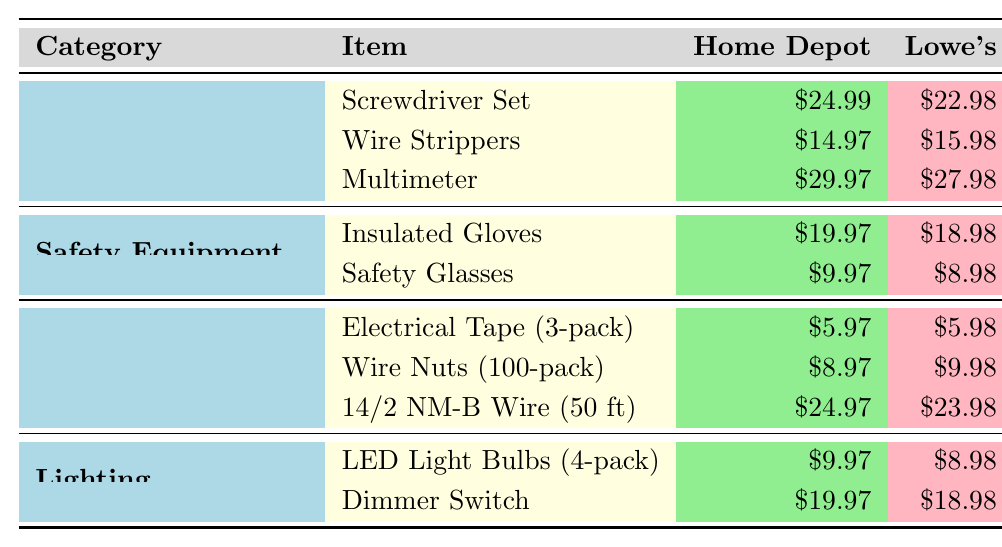What is the cheapest item in the Hand Tools category? The items listed under Hand Tools are Screwdriver Set ($24.99), Wire Strippers ($14.97), and Multimeter ($29.97). Among these, Wire Strippers have the lowest price at $14.97.
Answer: $14.97 Which supplier offers the lowest price for Safety Glasses? The table shows that Safety Glasses are priced at Home Depot ($9.97), Lowe's ($8.98), and Amazon ($7.99). Amazon has the lowest price for this item.
Answer: Amazon What is the price difference between LED Light Bulbs at Home Depot and Lowe's? LED Light Bulbs are $9.97 at Home Depot and $8.98 at Lowe's. To find the difference, subtract the price at Lowe's from the price at Home Depot: $9.97 - $8.98 = $0.99.
Answer: $0.99 What is the average price of the items in the Safety Equipment category? The prices for the items in this category are Insulated Gloves ($19.97) and Safety Glasses ($9.97). Their total price is $19.97 + $9.97 = $29.94, and there are 2 items. The average price is $29.94 / 2 = $14.97.
Answer: $14.97 Which supplier has the highest total cost for the items listed in the Electrical Materials category? The total costs for each supplier in Electrical Materials can be calculated: Home Depot: $5.97 + $8.97 + $24.97 = $39.91; Lowe's: $5.98 + $9.98 + $23.98 = $39.94; Amazon: $4.99 + $7.99 + $22.99 = $35.97. Lowe's has the highest total cost of $39.94.
Answer: Lowe's Is it true that all items in the Lighting category are cheaper at Amazon than at Home Depot? The prices for LED Light Bulbs are $9.97 at Home Depot and $7.99 at Amazon; for the Dimmer Switch, they are $19.97 at Home Depot and $17.99 at Amazon. Both items are cheaper at Amazon compared to Home Depot, confirming the statement is true.
Answer: True Which item has the largest price difference between Amazon and Lowe's? To find the largest price difference, calculate the differences for each item: Screwdriver Set: $24.99 - $19.99 = $5.00; Wire Strippers: $15.98 - $12.99 = $2.99; Multimeter: $27.98 - $25.99 = $1.99; Insulated Gloves: $18.98 - $17.99 = $0.99; Safety Glasses: $8.98 - $7.99 = $0.99; Electrical Tape: $5.98 - $4.99 = $0.99; Wire Nuts: $9.98 - $7.99 = $1.99; 14/2 NM-B Wire: $23.98 - $22.99 = $0.99; LED Light Bulbs: $8.98 - $7.99 = $0.99; Dimmer Switch: $18.98 - $17.99 = $0.99. The largest difference is $5.00 for the Screwdriver Set.
Answer: $5.00 